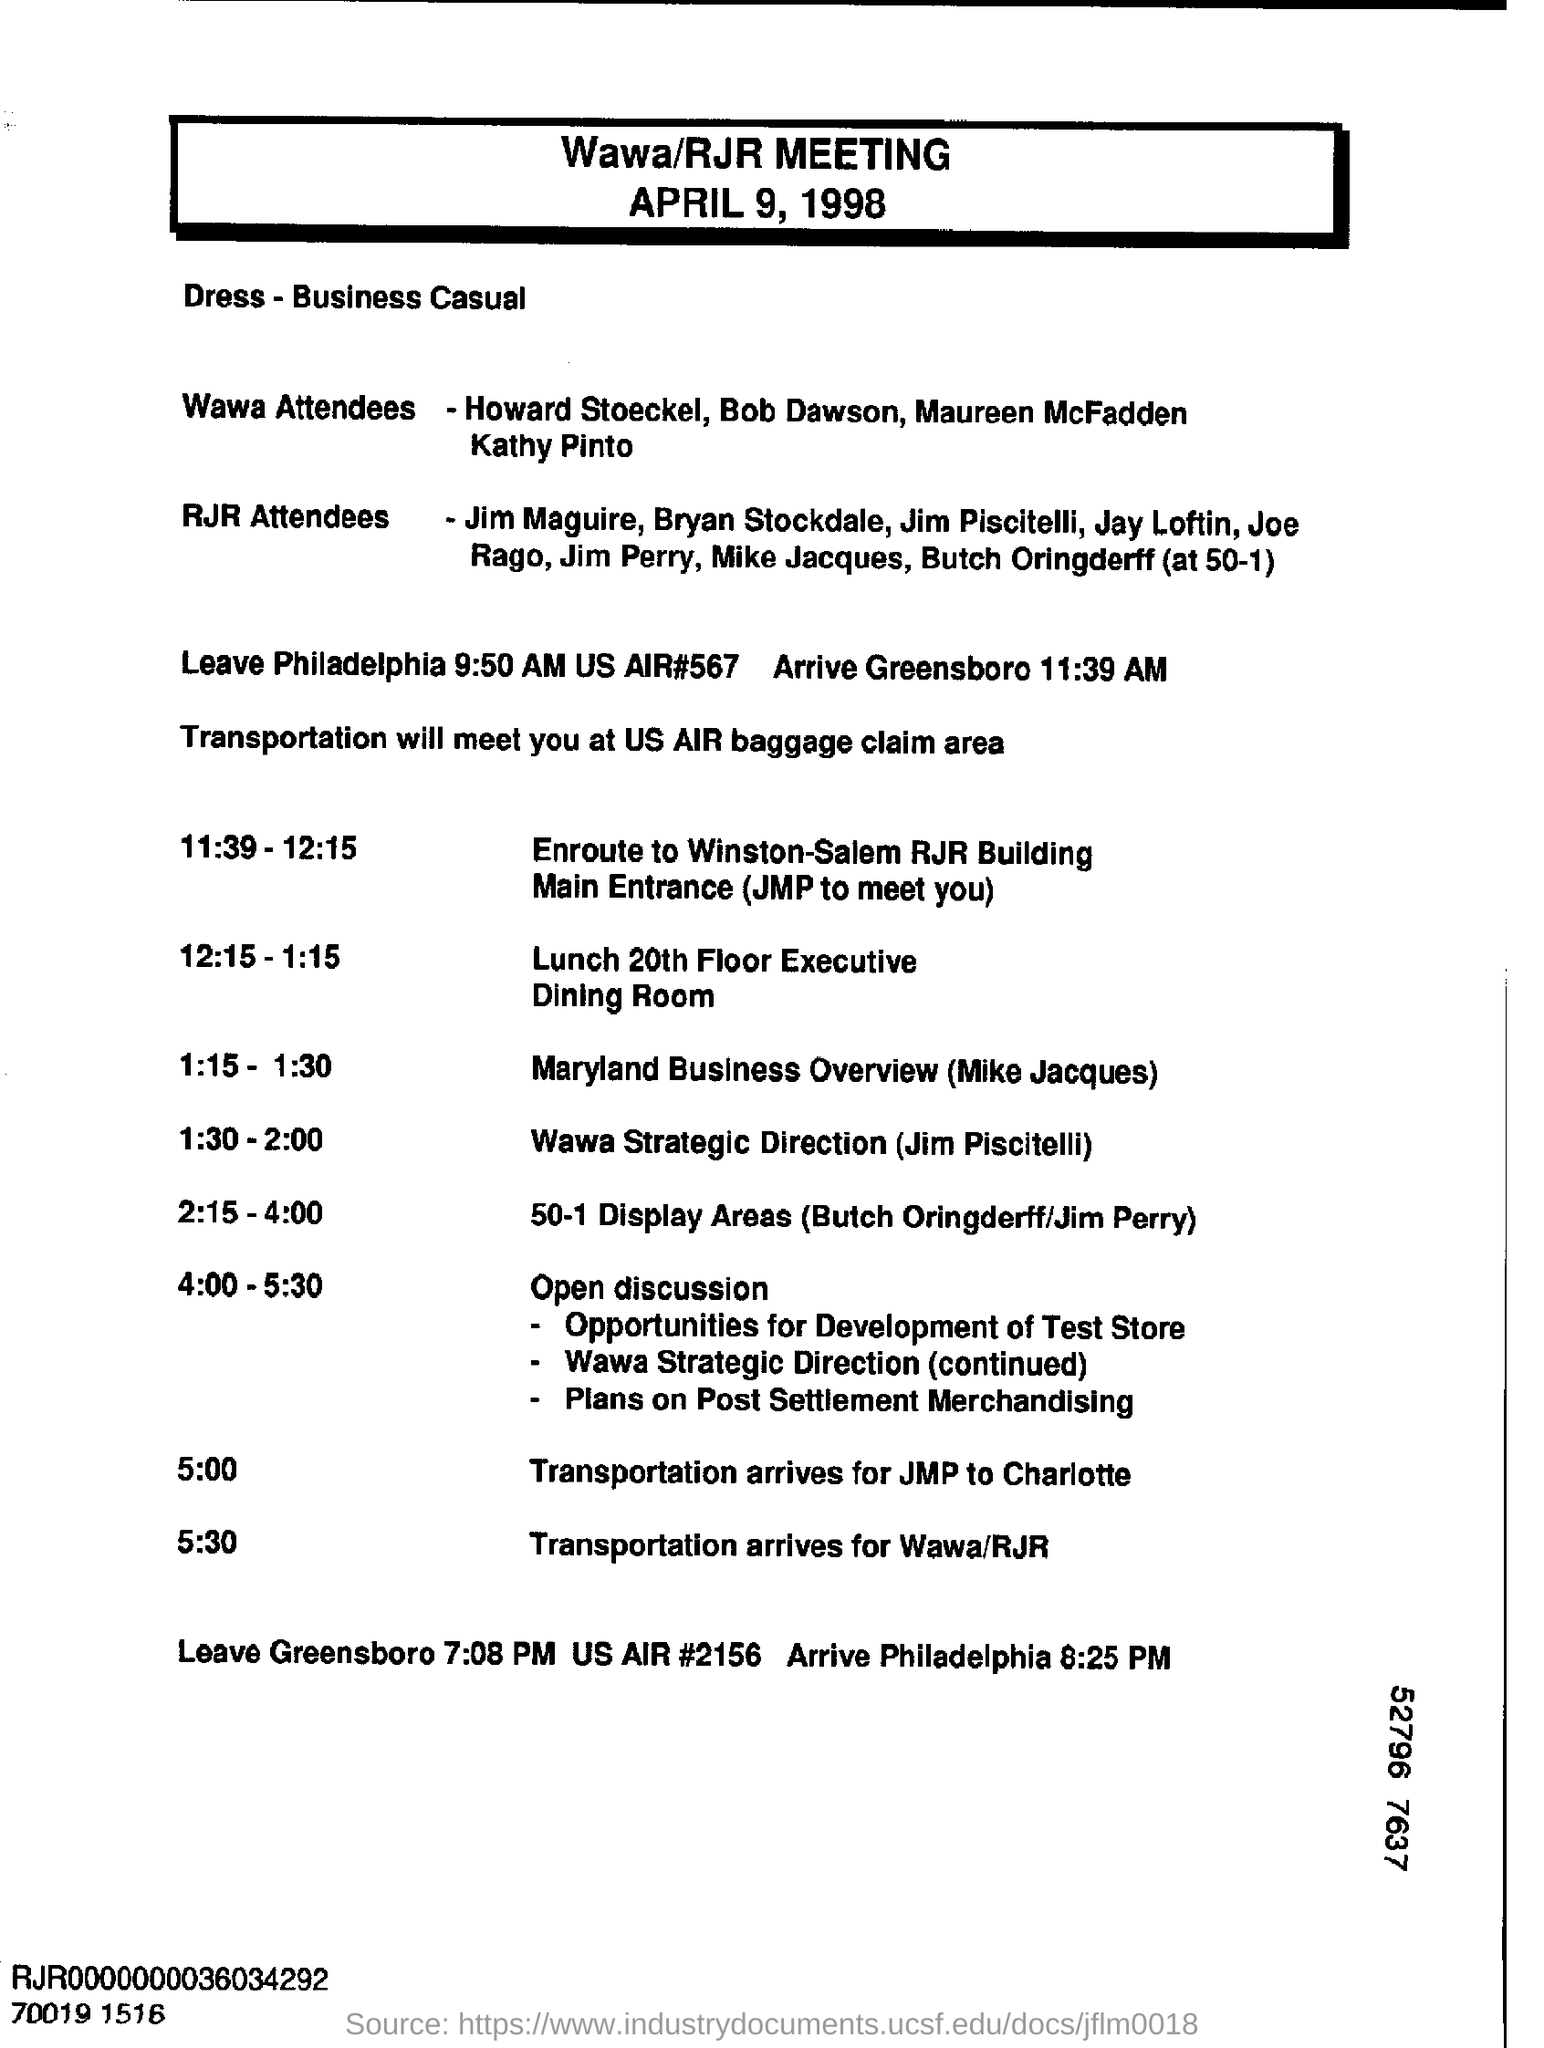Highlight a few significant elements in this photo. Transportation for Wawa/RJR is scheduled to arrive at 5:30 PM. The agenda for the Wawa/RJR meeting has been determined. The person who speaks about Wawa's strategic direction is Jim Piscitelli. The meeting will be held on April 9, 1998. Please advise the location of the transportation meeting point, which is at the US air baggage claim area. 